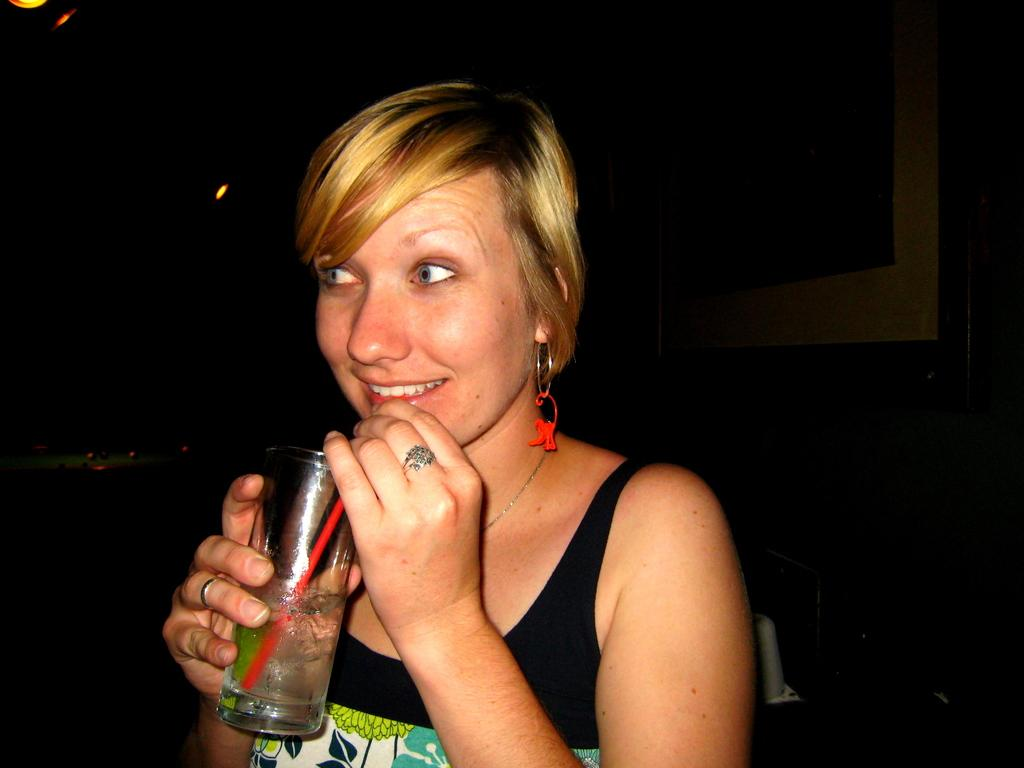Who is the main subject in the image? There is a woman in the image. What is the woman holding in the image? The woman is holding a glass of drink. Can you describe the glass of drink? The glass of drink has a straw in it. What is the color of the background in the image? The background of the image is dark. What type of lace is the woman wearing in the image? There is no mention of lace in the image, so it cannot be determined if the woman is wearing any. 